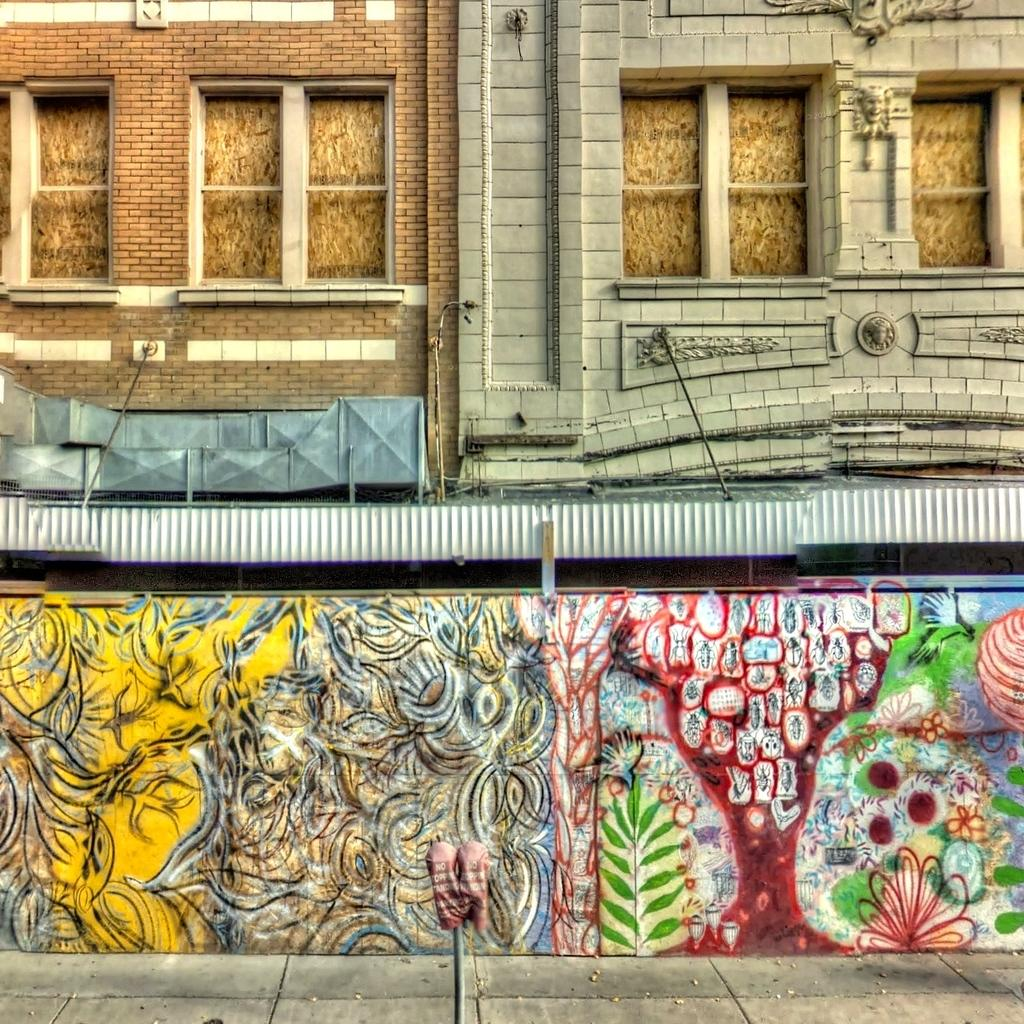What is the main structure in the center of the image? There is a wall in the center of the image. What is on the wall? Graffiti is present on the wall. What can be seen at the top of the wall? Windows are visible at the top of the wall. What is visible at the bottom of the image? The ground is visible at the bottom of the image. What type of brush is being used to paint the sweater in the image? There is no sweater or brush present in the image; it features a wall with graffiti. How many rails can be seen supporting the wall in the image? There are no rails visible in the image; the wall stands independently. 